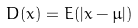Convert formula to latex. <formula><loc_0><loc_0><loc_500><loc_500>D ( x ) = E ( | x - \mu | )</formula> 